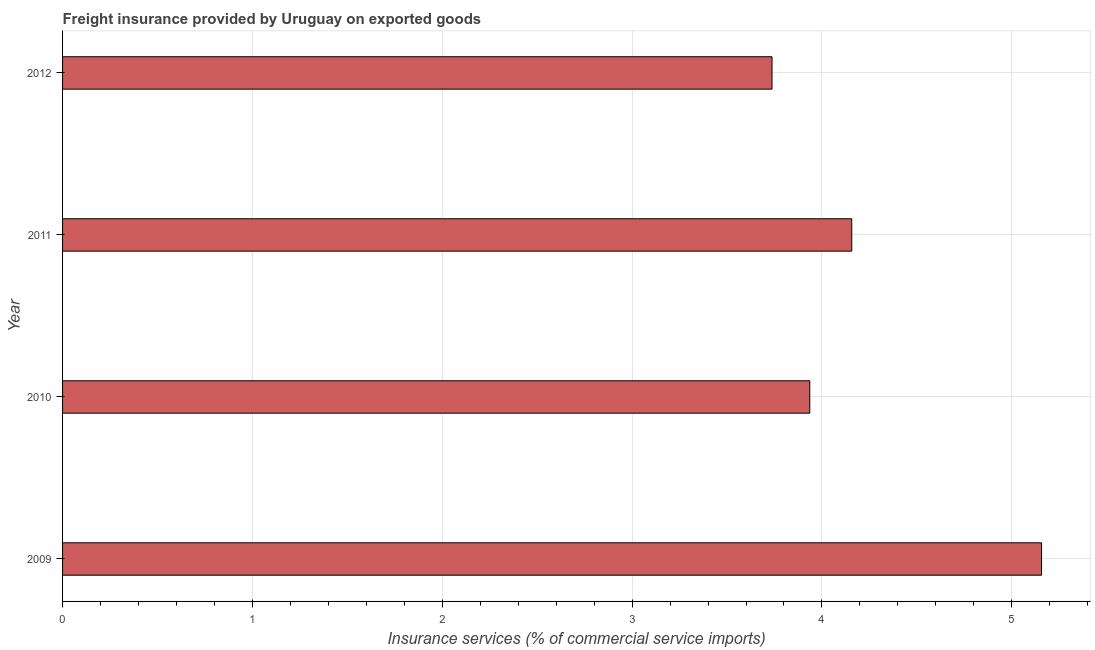Does the graph contain grids?
Make the answer very short. Yes. What is the title of the graph?
Keep it short and to the point. Freight insurance provided by Uruguay on exported goods . What is the label or title of the X-axis?
Give a very brief answer. Insurance services (% of commercial service imports). What is the freight insurance in 2009?
Provide a succinct answer. 5.16. Across all years, what is the maximum freight insurance?
Offer a terse response. 5.16. Across all years, what is the minimum freight insurance?
Your answer should be very brief. 3.74. In which year was the freight insurance maximum?
Your answer should be compact. 2009. In which year was the freight insurance minimum?
Give a very brief answer. 2012. What is the sum of the freight insurance?
Your answer should be compact. 16.99. What is the difference between the freight insurance in 2009 and 2010?
Give a very brief answer. 1.22. What is the average freight insurance per year?
Ensure brevity in your answer.  4.25. What is the median freight insurance?
Keep it short and to the point. 4.05. What is the ratio of the freight insurance in 2011 to that in 2012?
Make the answer very short. 1.11. Is the freight insurance in 2009 less than that in 2011?
Keep it short and to the point. No. Is the difference between the freight insurance in 2011 and 2012 greater than the difference between any two years?
Keep it short and to the point. No. What is the difference between the highest and the lowest freight insurance?
Provide a succinct answer. 1.42. In how many years, is the freight insurance greater than the average freight insurance taken over all years?
Ensure brevity in your answer.  1. What is the Insurance services (% of commercial service imports) of 2009?
Keep it short and to the point. 5.16. What is the Insurance services (% of commercial service imports) of 2010?
Your answer should be very brief. 3.94. What is the Insurance services (% of commercial service imports) in 2011?
Make the answer very short. 4.16. What is the Insurance services (% of commercial service imports) of 2012?
Your response must be concise. 3.74. What is the difference between the Insurance services (% of commercial service imports) in 2009 and 2010?
Provide a short and direct response. 1.22. What is the difference between the Insurance services (% of commercial service imports) in 2009 and 2011?
Ensure brevity in your answer.  1. What is the difference between the Insurance services (% of commercial service imports) in 2009 and 2012?
Keep it short and to the point. 1.42. What is the difference between the Insurance services (% of commercial service imports) in 2010 and 2011?
Provide a short and direct response. -0.22. What is the difference between the Insurance services (% of commercial service imports) in 2010 and 2012?
Keep it short and to the point. 0.2. What is the difference between the Insurance services (% of commercial service imports) in 2011 and 2012?
Provide a short and direct response. 0.42. What is the ratio of the Insurance services (% of commercial service imports) in 2009 to that in 2010?
Offer a terse response. 1.31. What is the ratio of the Insurance services (% of commercial service imports) in 2009 to that in 2011?
Your answer should be very brief. 1.24. What is the ratio of the Insurance services (% of commercial service imports) in 2009 to that in 2012?
Give a very brief answer. 1.38. What is the ratio of the Insurance services (% of commercial service imports) in 2010 to that in 2011?
Keep it short and to the point. 0.95. What is the ratio of the Insurance services (% of commercial service imports) in 2010 to that in 2012?
Keep it short and to the point. 1.05. What is the ratio of the Insurance services (% of commercial service imports) in 2011 to that in 2012?
Ensure brevity in your answer.  1.11. 